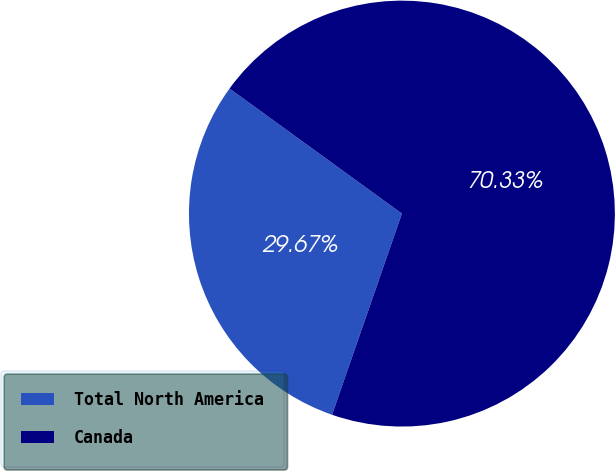<chart> <loc_0><loc_0><loc_500><loc_500><pie_chart><fcel>Total North America<fcel>Canada<nl><fcel>29.67%<fcel>70.33%<nl></chart> 